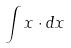<formula> <loc_0><loc_0><loc_500><loc_500>\int x \cdot d x</formula> 